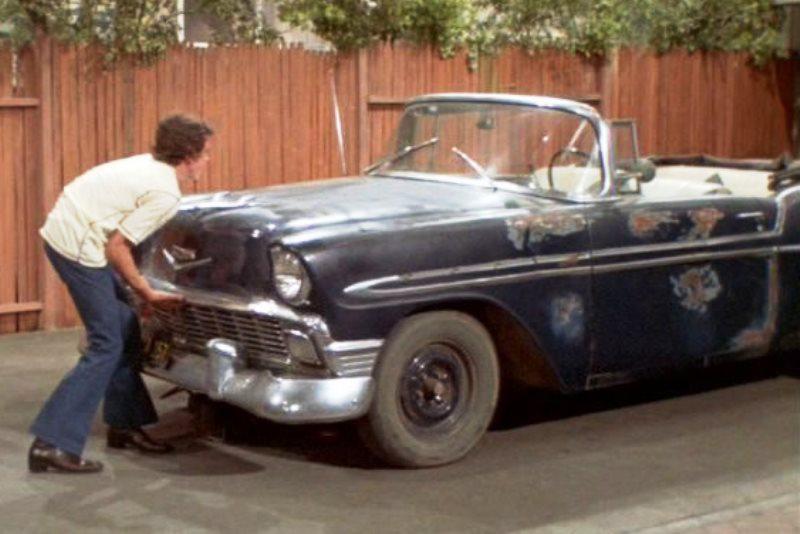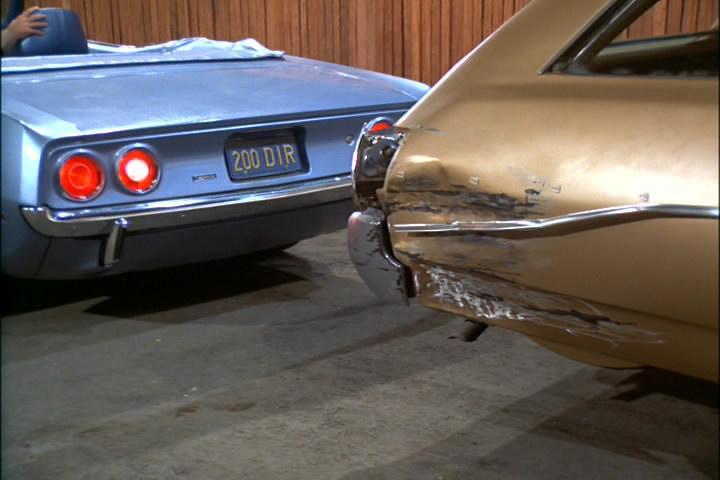The first image is the image on the left, the second image is the image on the right. For the images displayed, is the sentence "A young fellow bends and touches the front of a beat-up looking dark blue convertiblee." factually correct? Answer yes or no. Yes. 